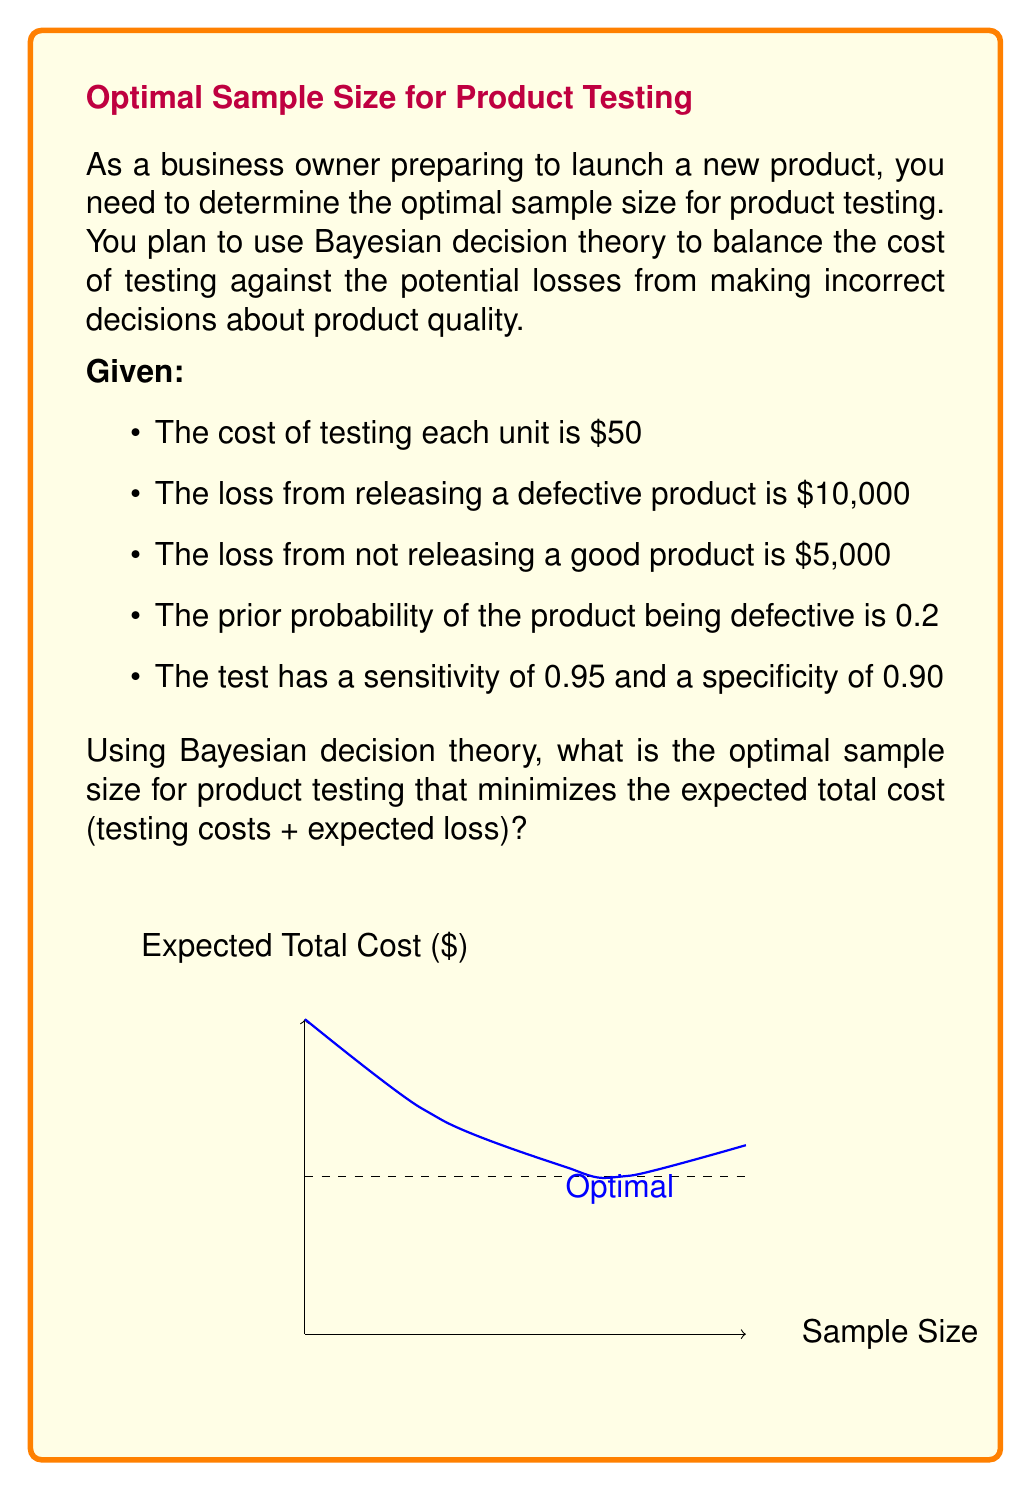Can you answer this question? To solve this problem using Bayesian decision theory, we need to follow these steps:

1) First, let's define our variables:
   $n$ = sample size
   $c$ = cost per test = $50
   $L_d$ = loss from releasing a defective product = $10,000
   $L_g$ = loss from not releasing a good product = $5,000
   $p$ = prior probability of the product being defective = 0.2
   $\text{sens}$ = sensitivity of the test = 0.95
   $\text{spec}$ = specificity of the test = 0.90

2) The expected total cost (ETC) is the sum of testing costs and expected loss:

   $ETC(n) = cn + E[\text{Loss}]$

3) To calculate the expected loss, we need to consider four scenarios:
   a) True Positive (TP): Defective product correctly identified
   b) False Negative (FN): Defective product incorrectly passed
   c) True Negative (TN): Good product correctly passed
   d) False Positive (FP): Good product incorrectly failed

4) The probabilities for these scenarios are:
   $P(TP) = p \cdot \text{sens}$
   $P(FN) = p \cdot (1 - \text{sens})$
   $P(TN) = (1-p) \cdot \text{spec}$
   $P(FP) = (1-p) \cdot (1 - \text{spec})$

5) The expected loss is:
   $E[\text{Loss}] = L_d \cdot P(FN) + L_g \cdot P(FP)$

6) Substituting the values:
   $E[\text{Loss}] = 10000 \cdot (0.2 \cdot 0.05) + 5000 \cdot (0.8 \cdot 0.1) = 100 + 400 = 500$

7) Now, the expected total cost function is:
   $ETC(n) = 50n + 500$

8) To find the optimal sample size, we need to consider the probability of making a correct decision after $n$ tests. This probability increases with $n$ but with diminishing returns.

9) A common approach is to use the formula:
   $n_{opt} = \sqrt{\frac{2 \cdot E[\text{Loss}]}{c \cdot \ln(1 + \frac{E[\text{Loss}]}{c})}}$

10) Substituting our values:
    $n_{opt} = \sqrt{\frac{2 \cdot 500}{50 \cdot \ln(1 + \frac{500}{50})}} \approx 13.4$

11) Since we can't test a fractional number of units, we round to the nearest whole number.
Answer: 13 units 